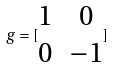Convert formula to latex. <formula><loc_0><loc_0><loc_500><loc_500>g = [ \begin{matrix} 1 & 0 \\ 0 & - 1 \end{matrix} ]</formula> 